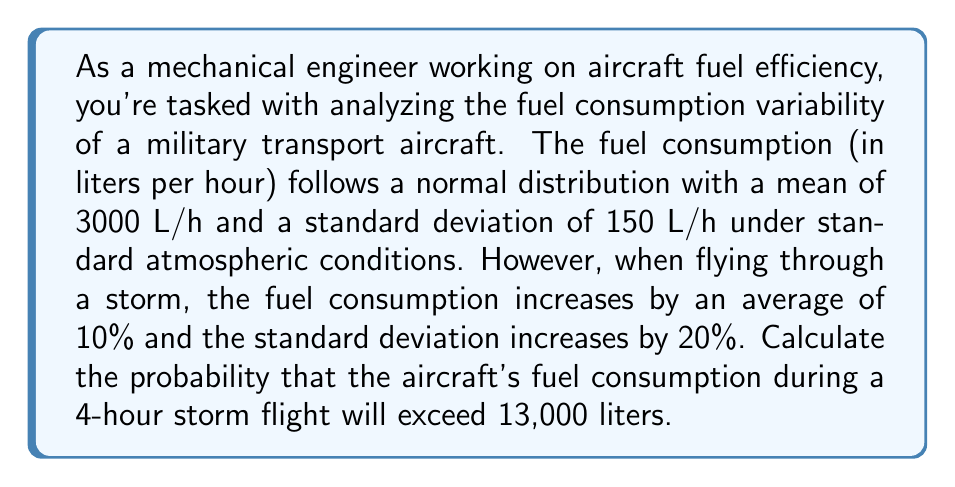What is the answer to this math problem? Let's approach this step-by-step:

1) First, let's define our variables:
   $X$ = Fuel consumption under normal conditions (L/h)
   $Y$ = Fuel consumption during storm conditions (L/h)

2) We're given:
   $X \sim N(3000, 150^2)$
   $E[Y] = 1.10 \cdot E[X] = 1.10 \cdot 3000 = 3300$ L/h
   $\sigma_Y = 1.20 \cdot \sigma_X = 1.20 \cdot 150 = 180$ L/h

3) So, $Y \sim N(3300, 180^2)$

4) We need to find $P(4Y > 13000)$

5) Let $Z = 4Y$ (total fuel consumption over 4 hours)
   $E[Z] = 4E[Y] = 4 \cdot 3300 = 13200$ L
   $\sigma_Z = 4\sigma_Y = 4 \cdot 180 = 720$ L

6) So, $Z \sim N(13200, 720^2)$

7) We need to find $P(Z > 13000)$

8) Standardizing:
   $P(Z > 13000) = P(\frac{Z - 13200}{720} > \frac{13000 - 13200}{720})$
                 $= P(Z_0 > -\frac{200}{720})$
                 $= P(Z_0 > -0.2778)$

9) Using the standard normal table or calculator:
   $P(Z_0 > -0.2778) = 1 - P(Z_0 < -0.2778) = 1 - 0.3906 = 0.6094$

Therefore, the probability is approximately 0.6094 or 60.94%.
Answer: 0.6094 